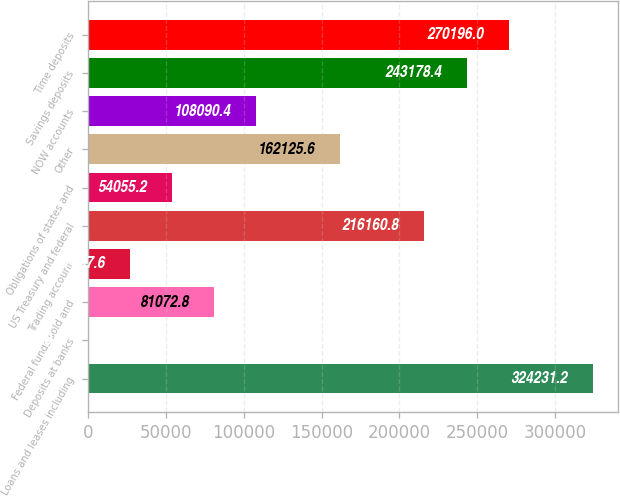Convert chart. <chart><loc_0><loc_0><loc_500><loc_500><bar_chart><fcel>Loans and leases including<fcel>Deposits at banks<fcel>Federal funds sold and<fcel>Trading account<fcel>US Treasury and federal<fcel>Obligations of states and<fcel>Other<fcel>NOW accounts<fcel>Savings deposits<fcel>Time deposits<nl><fcel>324231<fcel>20<fcel>81072.8<fcel>27037.6<fcel>216161<fcel>54055.2<fcel>162126<fcel>108090<fcel>243178<fcel>270196<nl></chart> 